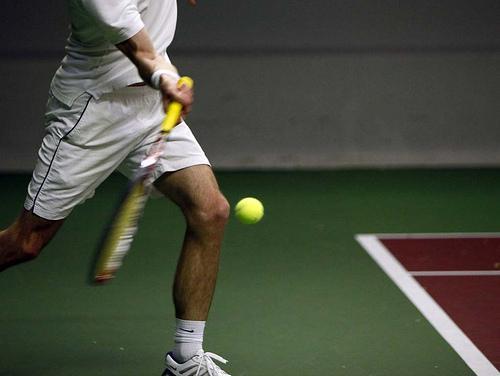How many tracks have a train on them?
Give a very brief answer. 0. 